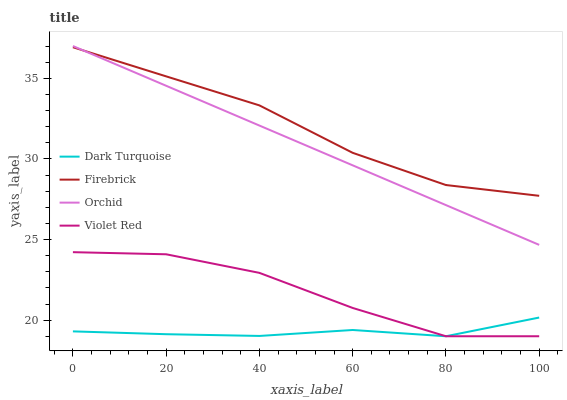Does Dark Turquoise have the minimum area under the curve?
Answer yes or no. Yes. Does Firebrick have the maximum area under the curve?
Answer yes or no. Yes. Does Violet Red have the minimum area under the curve?
Answer yes or no. No. Does Violet Red have the maximum area under the curve?
Answer yes or no. No. Is Orchid the smoothest?
Answer yes or no. Yes. Is Violet Red the roughest?
Answer yes or no. Yes. Is Firebrick the smoothest?
Answer yes or no. No. Is Firebrick the roughest?
Answer yes or no. No. Does Firebrick have the lowest value?
Answer yes or no. No. Does Firebrick have the highest value?
Answer yes or no. No. Is Violet Red less than Firebrick?
Answer yes or no. Yes. Is Firebrick greater than Violet Red?
Answer yes or no. Yes. Does Violet Red intersect Firebrick?
Answer yes or no. No. 